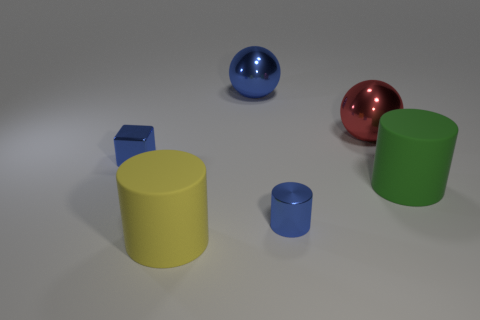How does the size of the blue spherical object compare to the other objects in the image? The blue spherical object is mid-sized when compared to the other objects. It is larger than the solid blue and small yellow cylinders while being smaller than the green cylinder and the large yellow cylinder. 